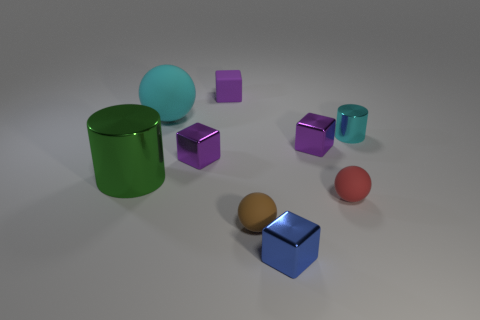There is a cyan object that is on the left side of the tiny cylinder; what is its shape?
Provide a short and direct response. Sphere. There is another cyan cylinder that is made of the same material as the large cylinder; what size is it?
Provide a succinct answer. Small. What is the shape of the rubber object that is in front of the purple rubber cube and behind the big metal cylinder?
Give a very brief answer. Sphere. There is a small rubber thing to the right of the tiny brown matte object; is its color the same as the big rubber sphere?
Your answer should be compact. No. Do the cyan thing that is right of the tiny brown ball and the purple thing that is to the right of the blue metal object have the same shape?
Offer a terse response. No. There is a purple thing on the right side of the tiny blue object; how big is it?
Offer a terse response. Small. How big is the cyan thing behind the tiny thing on the right side of the small red matte thing?
Ensure brevity in your answer.  Large. Is the number of large green metallic things greater than the number of tiny balls?
Offer a very short reply. No. Is the number of green cylinders that are in front of the small red matte thing greater than the number of small blue metallic things that are behind the tiny blue metallic block?
Ensure brevity in your answer.  No. There is a metallic thing that is both on the right side of the big green shiny thing and to the left of the small brown ball; what is its size?
Your answer should be very brief. Small. 